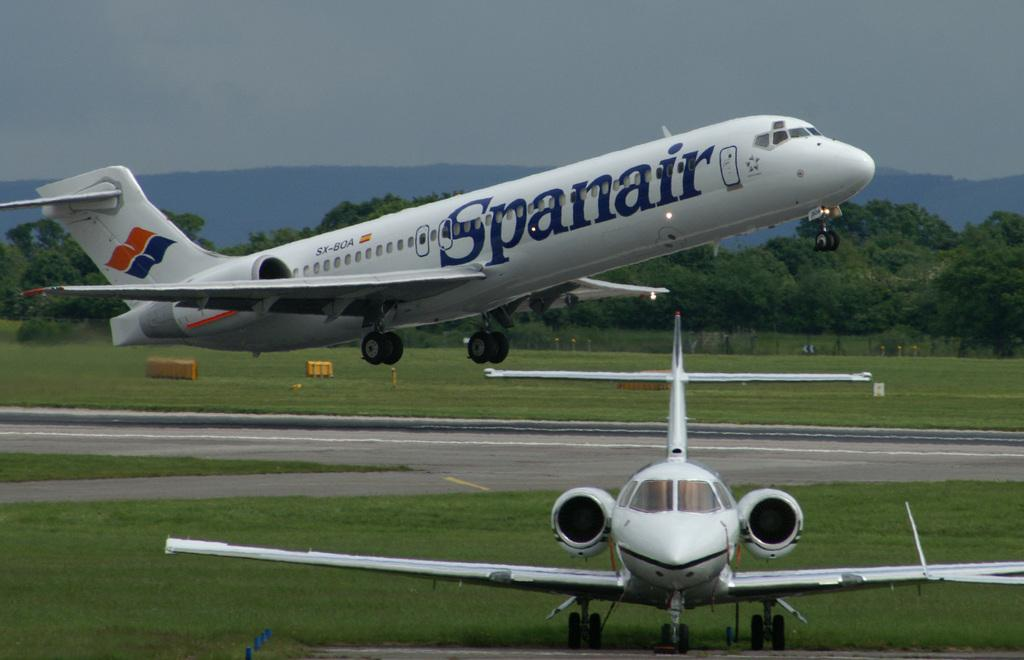What is the main subject of the image? The main subject of the image is aeroplanes. What can be seen below the aeroplanes in the image? The ground is visible in the image. What type of natural features can be seen in the image? There are hills and trees in the image. What is visible above the aeroplanes in the image? The sky is visible in the image. What type of spoon is being used to stir the weather in the image? There is no spoon or weather present in the image; it features aeroplanes, hills, trees, and the sky. 